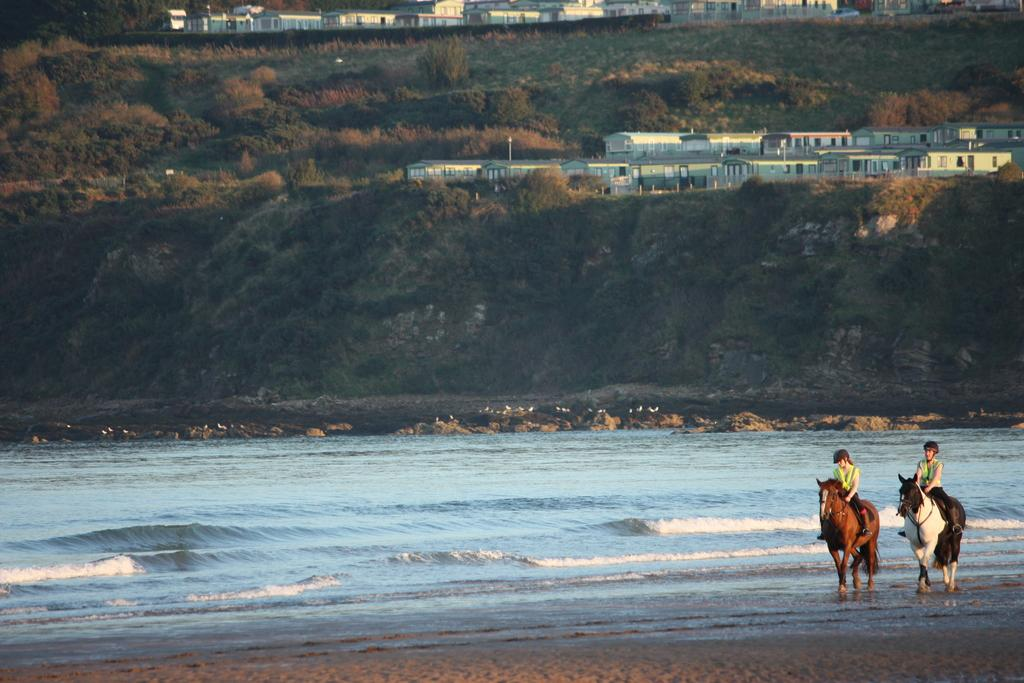How many people are in the image? There are two persons in the image. What are the persons doing in the image? The persons are riding horses. Where are the horses located in the image? The horses are in front of a beach. What can be seen in the background of the image? There is a hill visible in the background, and there are buildings on the hill. What type of lip balm is the person on the left using in the image? There is no lip balm or any indication of its use in the image. What type of rice is being cooked in the background of the image? There is no rice or any cooking activity visible in the image. 